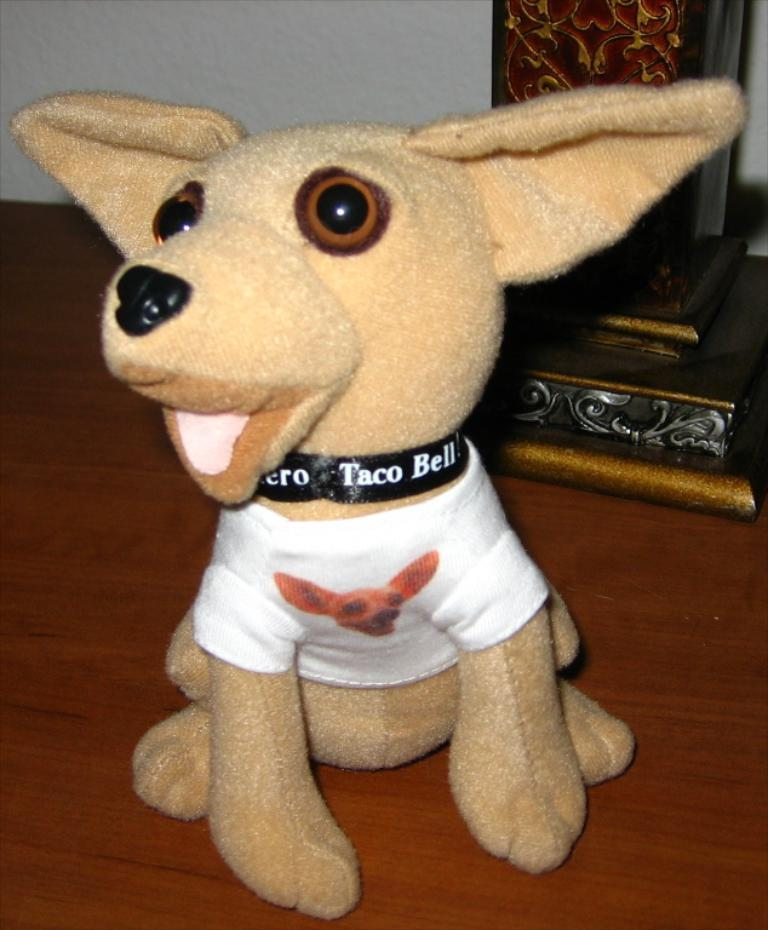What is placed on the floor in the image? There is a doll on the floor in the image. What can be seen in the background of the image? There is a wall and a pillar in the background of the image. What type of dirt is visible on the shelf in the image? There is no shelf present in the image, and therefore no dirt can be observed on it. 